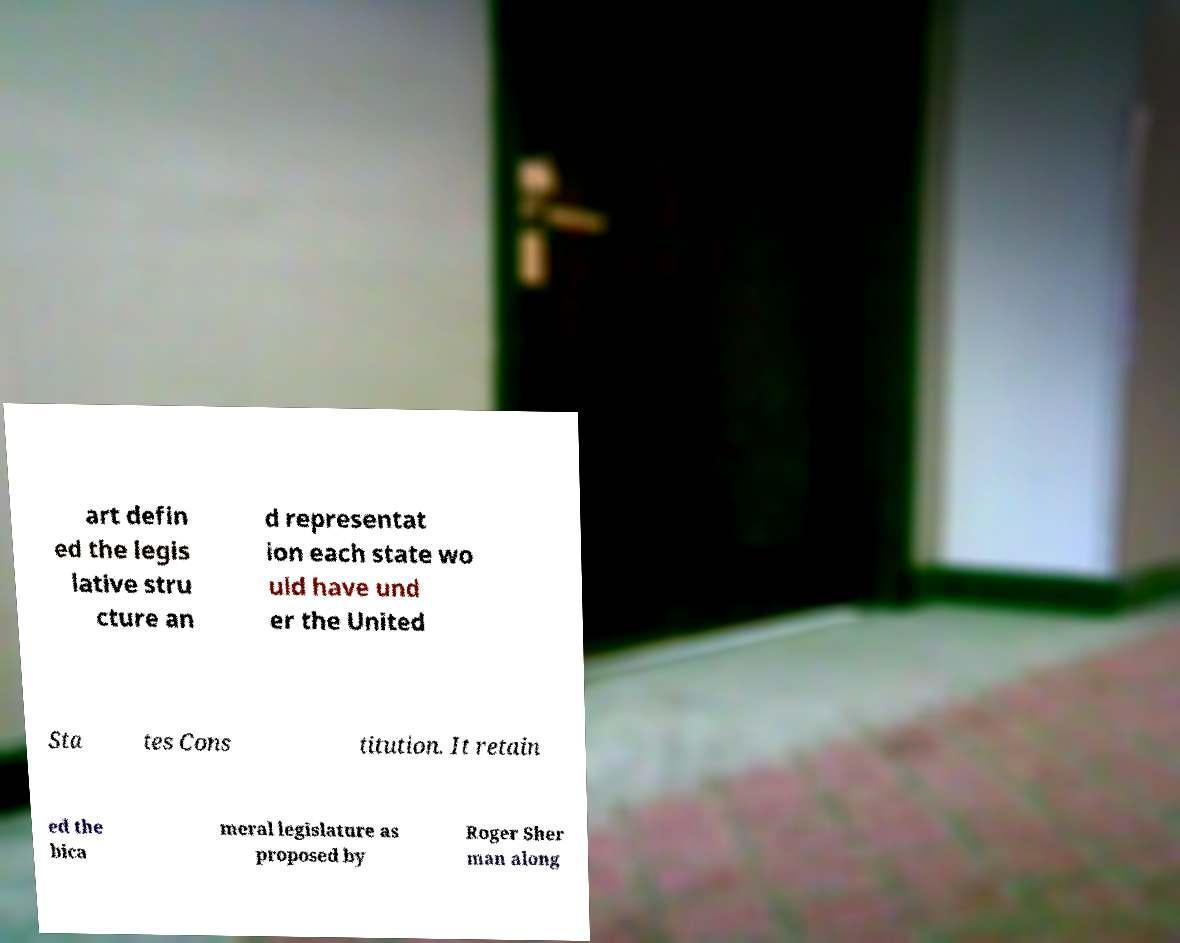I need the written content from this picture converted into text. Can you do that? art defin ed the legis lative stru cture an d representat ion each state wo uld have und er the United Sta tes Cons titution. It retain ed the bica meral legislature as proposed by Roger Sher man along 